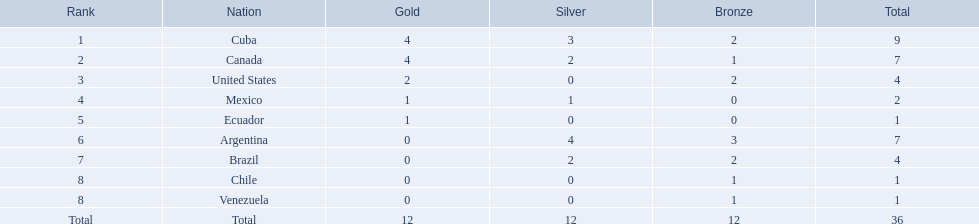Which nations won gold medals? Cuba, Canada, United States, Mexico, Ecuador. How many medals did each nation win? Cuba, 9, Canada, 7, United States, 4, Mexico, 2, Ecuador, 1. Which nation only won a gold medal? Ecuador. Which nations won a gold medal in canoeing in the 2011 pan american games? Cuba, Canada, United States, Mexico, Ecuador. Which of these did not win any silver medals? United States. 